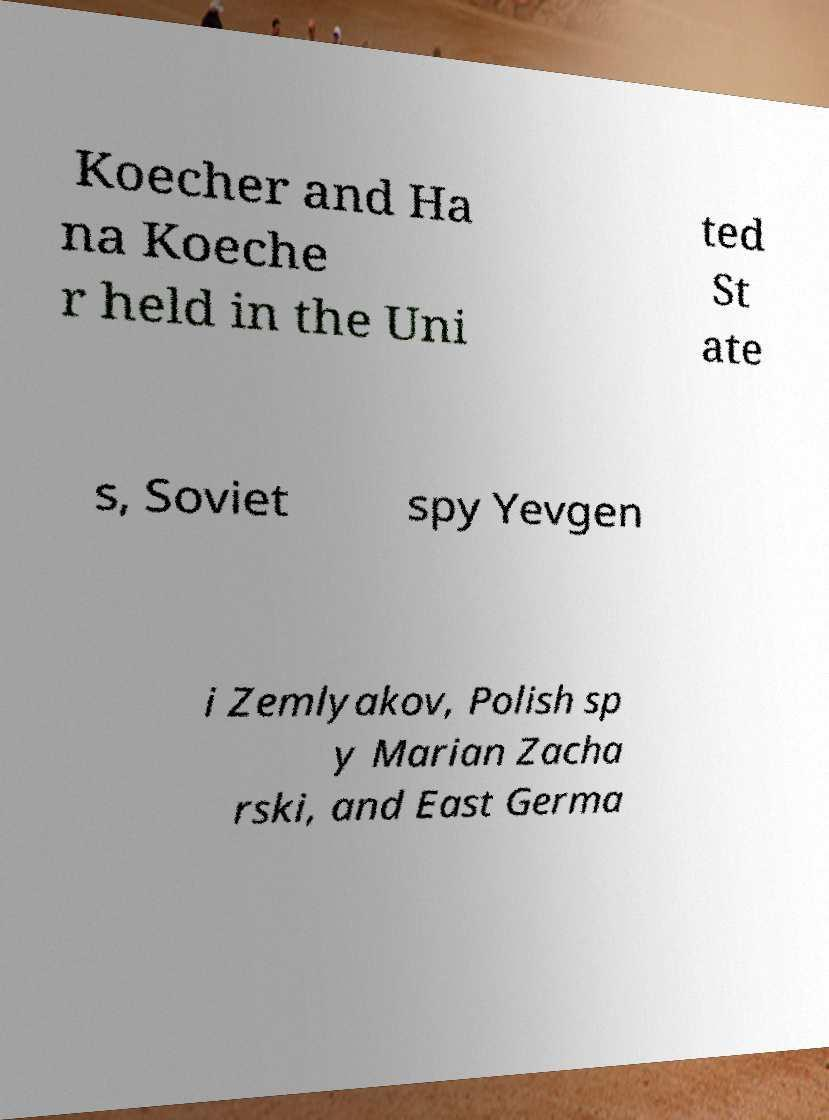For documentation purposes, I need the text within this image transcribed. Could you provide that? Koecher and Ha na Koeche r held in the Uni ted St ate s, Soviet spy Yevgen i Zemlyakov, Polish sp y Marian Zacha rski, and East Germa 